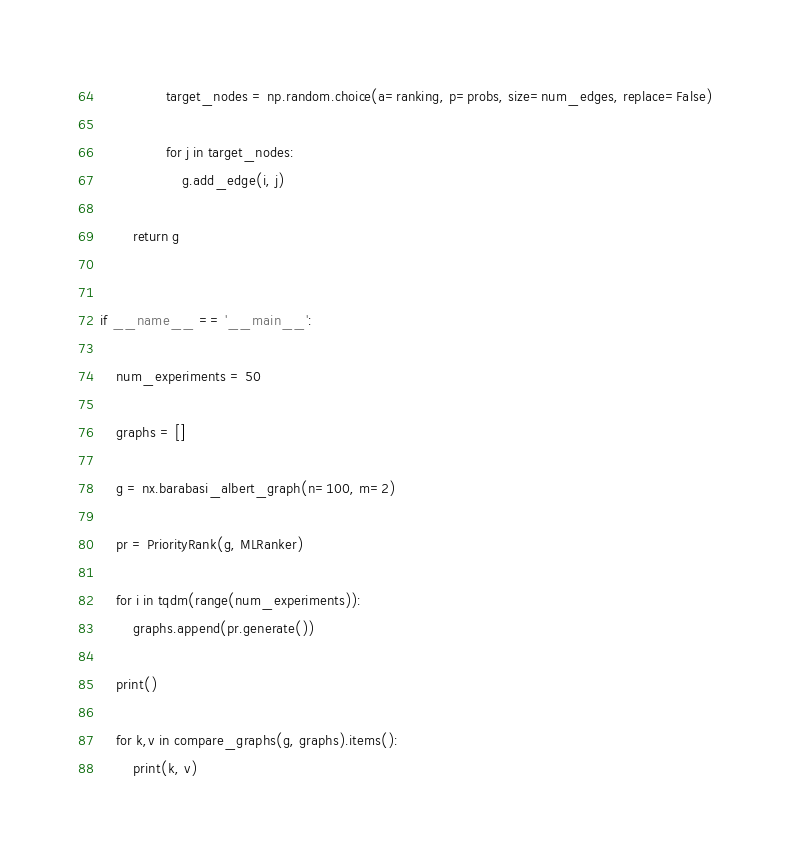<code> <loc_0><loc_0><loc_500><loc_500><_Python_>                target_nodes = np.random.choice(a=ranking, p=probs, size=num_edges, replace=False)

                for j in target_nodes:
                    g.add_edge(i, j)

        return g


if __name__ == '__main__':

    num_experiments = 50

    graphs = []

    g = nx.barabasi_albert_graph(n=100, m=2)

    pr = PriorityRank(g, MLRanker)

    for i in tqdm(range(num_experiments)):
        graphs.append(pr.generate())

    print()

    for k,v in compare_graphs(g, graphs).items():
        print(k, v)
</code> 